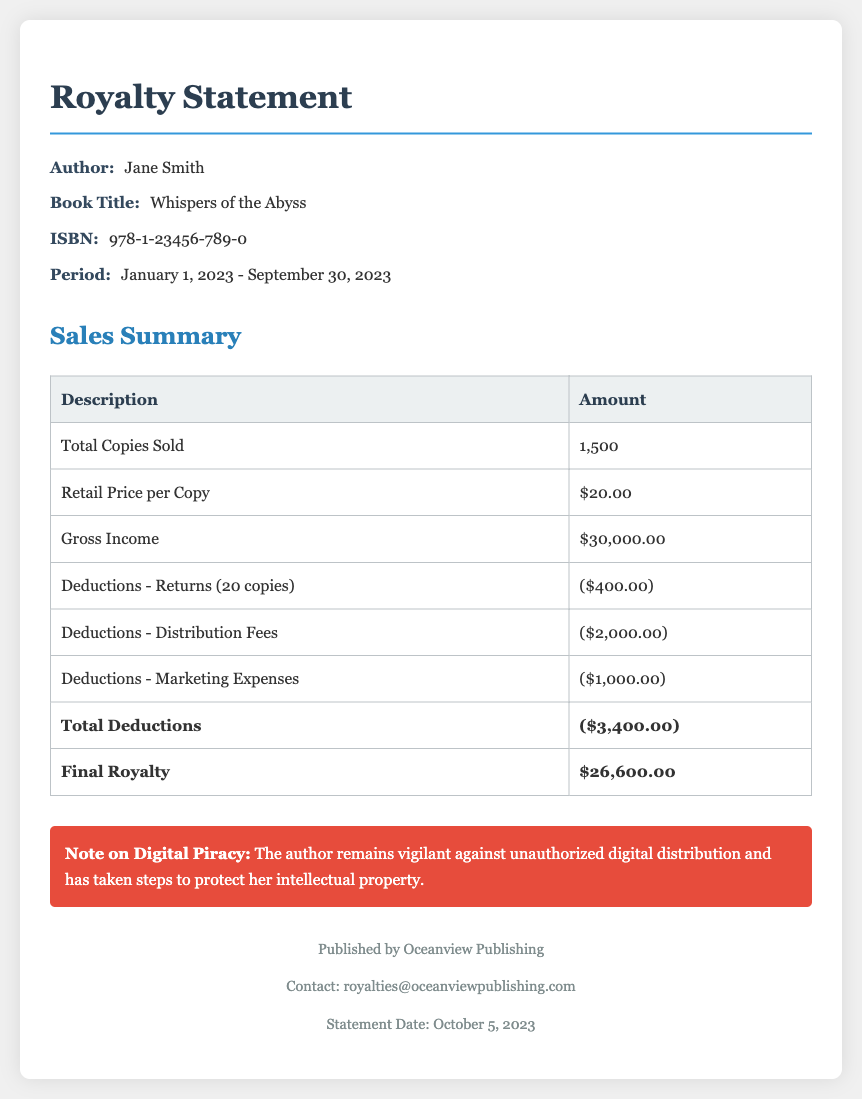What is the author's name? The author's name is specifically mentioned in the document as Jane Smith.
Answer: Jane Smith What is the title of the book? The title of the book can be found in the document and is Whispers of the Abyss.
Answer: Whispers of the Abyss How many copies were sold? The document states that a total of 1,500 copies were sold, which is explicitly listed under Total Copies Sold.
Answer: 1,500 What is the gross income generated from sales? The gross income is detailed in the table and stated to be $30,000.00.
Answer: $30,000.00 What amount was deducted for returns? The document indicates that the deductions for returns amounted to $400.00.
Answer: $400.00 What is the total amount of deductions? The total deductions, as calculated in the document, sum up to $3,400.00.
Answer: $3,400.00 What is the final royalty amount? The final royalty amount is clearly stated in the document as $26,600.00.
Answer: $26,600.00 During what period are the sales reported? The period for the sales is noted in the document as January 1, 2023 - September 30, 2023.
Answer: January 1, 2023 - September 30, 2023 What is the note on digital piracy? The note on digital piracy in the document emphasizes the author's vigilance against unauthorized distribution.
Answer: The author remains vigilant against unauthorized digital distribution and has taken steps to protect her intellectual property 